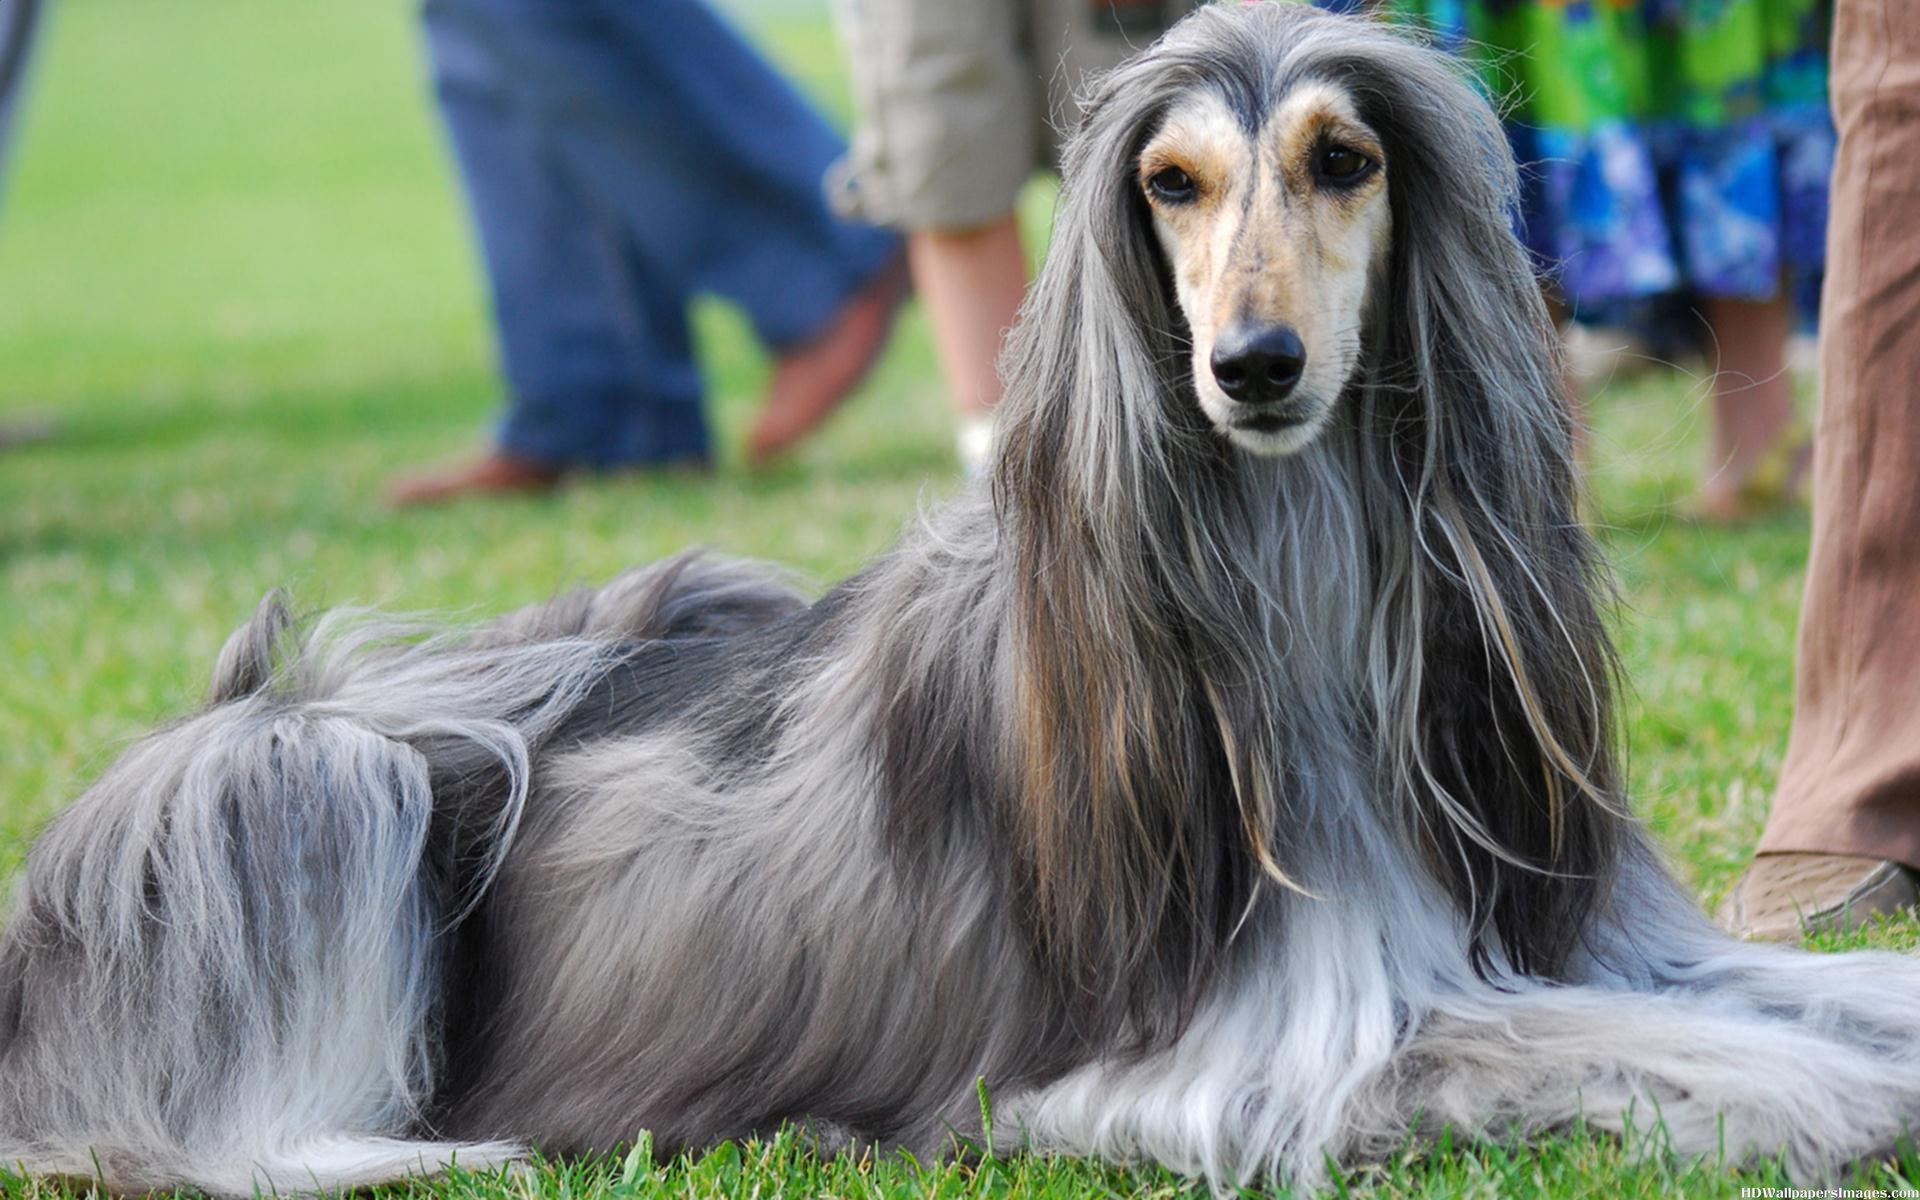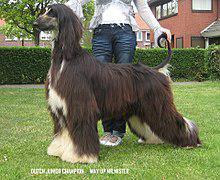The first image is the image on the left, the second image is the image on the right. For the images shown, is this caption "All dogs shown have mostly gray fur." true? Answer yes or no. No. 